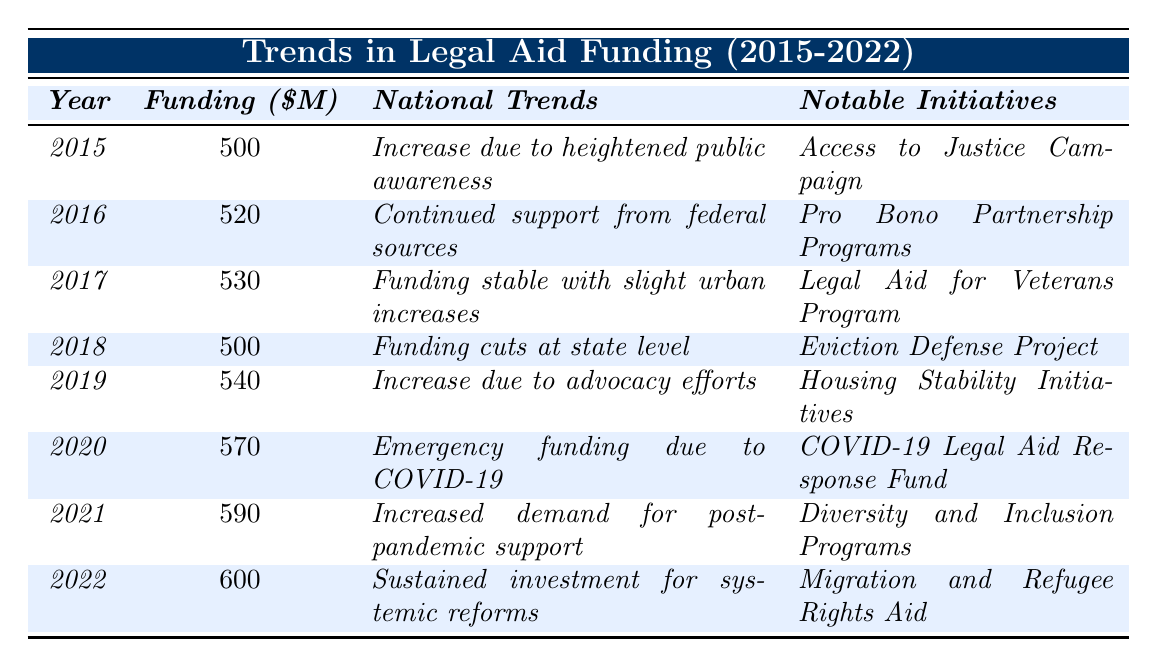What was the funding amount for legal aid in 2015? The table shows that the funding amount for legal aid in the year 2015 is 500 million dollars.
Answer: 500 million How much did legal aid funding increase from 2015 to 2016? The funding in 2015 was 500 million and in 2016 it was 520 million. The increase is 520 - 500 = 20 million.
Answer: 20 million In which year was the highest funding amount allocated and what was it? The highest funding amount is found in 2022, which is 600 million dollars.
Answer: 2022, 600 million What notable initiative was associated with legal aid funding in 2018? According to the table, the notable initiative linked to 2018 is the "Eviction Defense Project."
Answer: Eviction Defense Project What was the average legal aid funding from 2015 to 2022? The funding amounts are 500, 520, 530, 500, 540, 570, 590, and 600 million. Summing these amounts gives 4350 million, and dividing by 8 (the number of years) gives an average of 543.75 million.
Answer: 543.75 million Did the funding amount ever decrease from one year to the next between 2015 and 2022? Comparing the funding amounts year over year, it can be seen that the funding decreased from 2017 to 2018 (from 530 million to 500 million). So, the answer is yes.
Answer: Yes What major recipient received funding in 2020 during the COVID-19 pandemic? The table indicates that the "Legal Services Corporation" was a major recipient of funding in 2020.
Answer: Legal Services Corporation What change in funding amount occurred between 2021 and 2022? The funding amount in 2021 was 590 million and in 2022 it was 600 million. The change is 600 - 590 = 10 million, indicating an increase.
Answer: 10 million increase Which year had the lowest funding amount? The funding amounts show 500 million in both 2015 and 2018, making those the lowest years for funding.
Answer: 2015, 2018 What can be inferred about national trends in 2020 compared to 2019? In 2019, there was an increase due to advocacy efforts, whereas in 2020, emergency funding was provided due to the COVID-19 pandemic. This indicates a shift from a focus on advocacy to urgent crisis response.
Answer: Shift from advocacy to emergency funding 